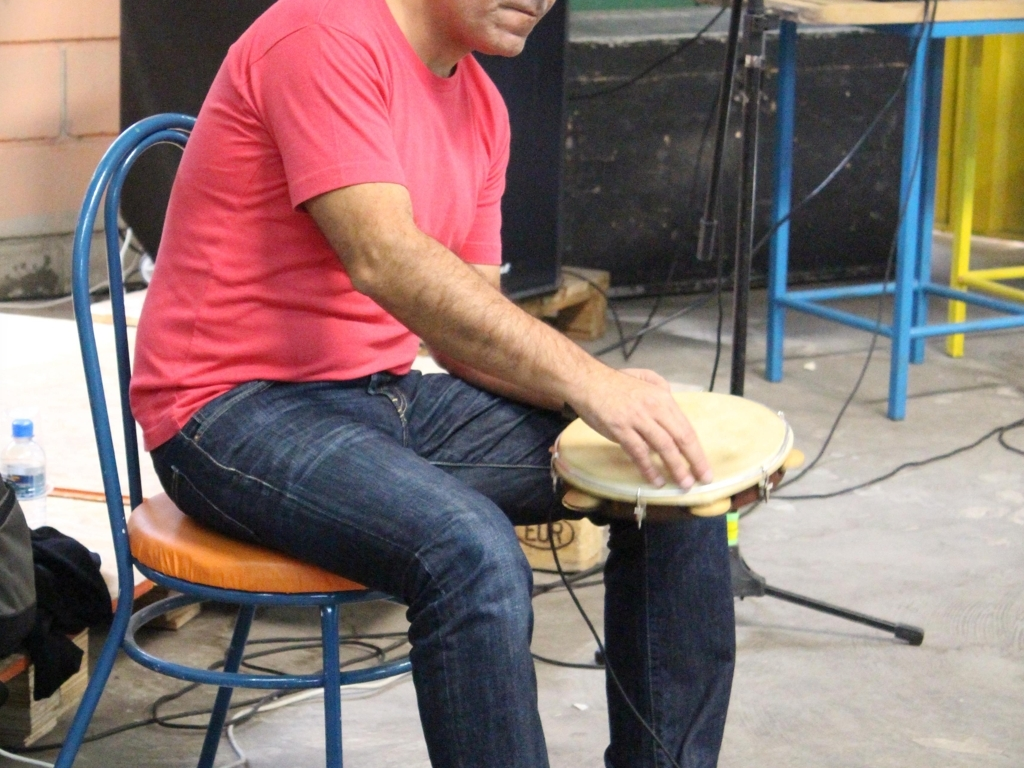Is the subject showing their full face?
A. No
B. Yes
Answer with the option's letter from the given choices directly.
 A. 